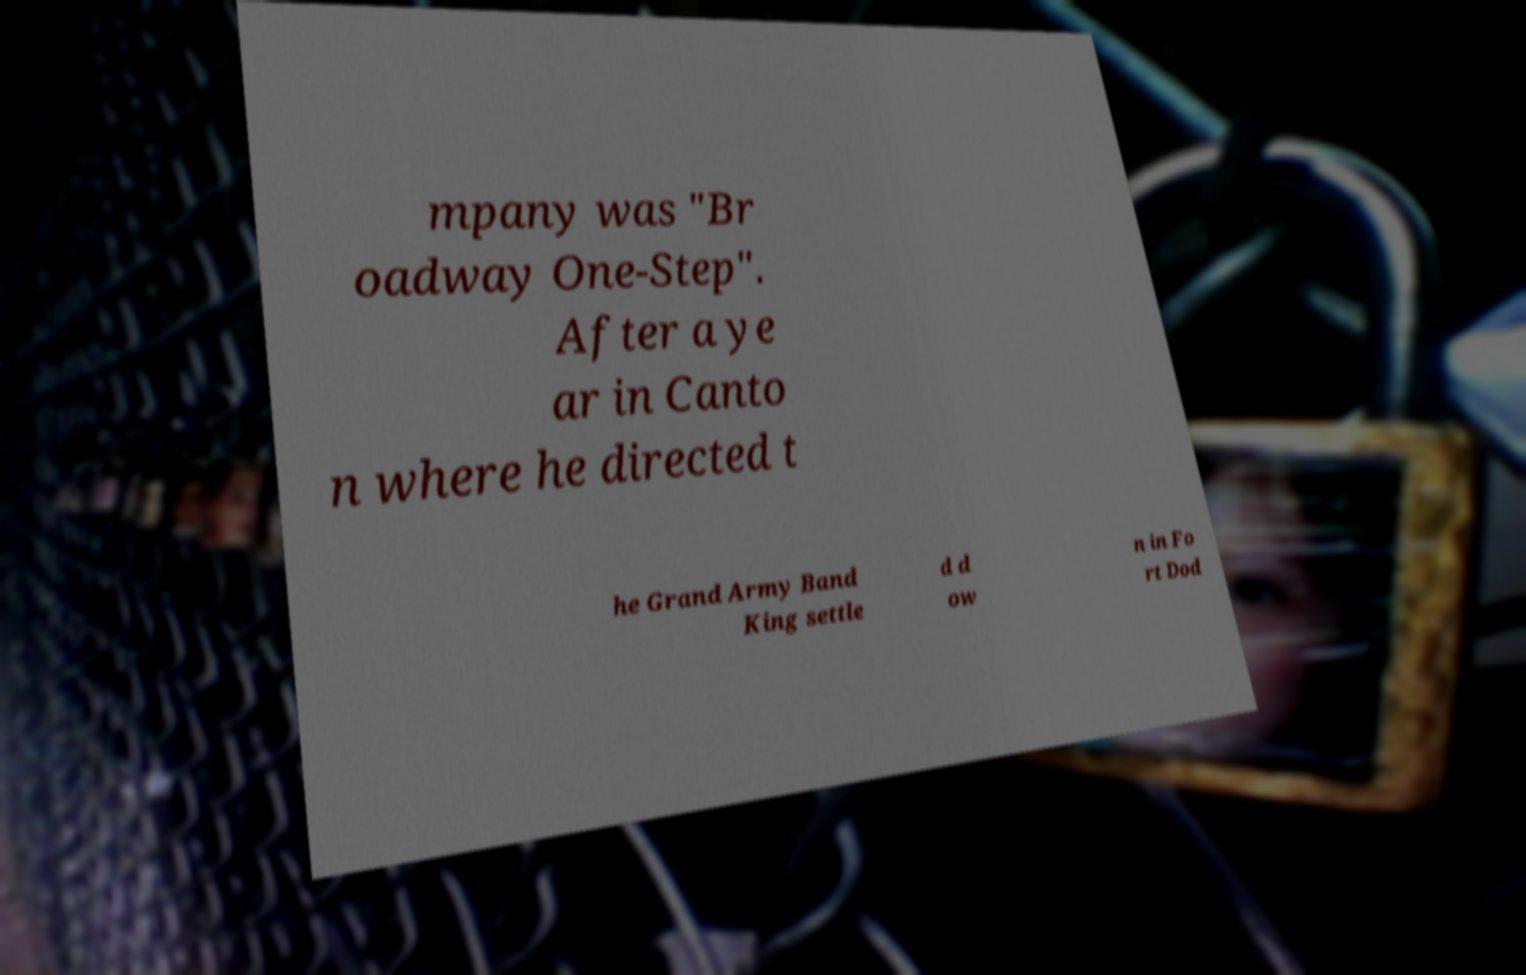Can you read and provide the text displayed in the image?This photo seems to have some interesting text. Can you extract and type it out for me? mpany was "Br oadway One-Step". After a ye ar in Canto n where he directed t he Grand Army Band King settle d d ow n in Fo rt Dod 